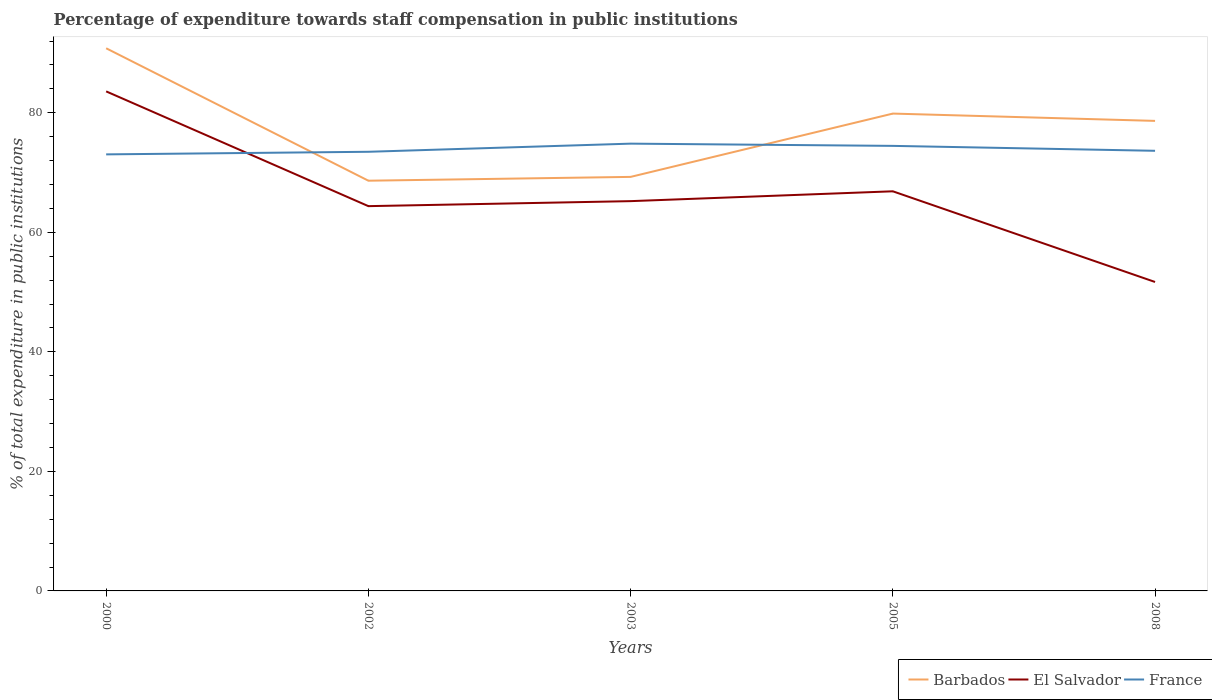Across all years, what is the maximum percentage of expenditure towards staff compensation in El Salvador?
Offer a very short reply. 51.69. What is the total percentage of expenditure towards staff compensation in France in the graph?
Give a very brief answer. -1.42. What is the difference between the highest and the second highest percentage of expenditure towards staff compensation in Barbados?
Offer a terse response. 22.16. How many lines are there?
Provide a succinct answer. 3. Does the graph contain grids?
Offer a very short reply. No. Where does the legend appear in the graph?
Your response must be concise. Bottom right. What is the title of the graph?
Ensure brevity in your answer.  Percentage of expenditure towards staff compensation in public institutions. What is the label or title of the X-axis?
Provide a short and direct response. Years. What is the label or title of the Y-axis?
Offer a terse response. % of total expenditure in public institutions. What is the % of total expenditure in public institutions of Barbados in 2000?
Offer a terse response. 90.8. What is the % of total expenditure in public institutions in El Salvador in 2000?
Offer a terse response. 83.58. What is the % of total expenditure in public institutions of France in 2000?
Make the answer very short. 73.04. What is the % of total expenditure in public institutions in Barbados in 2002?
Make the answer very short. 68.64. What is the % of total expenditure in public institutions of El Salvador in 2002?
Ensure brevity in your answer.  64.38. What is the % of total expenditure in public institutions of France in 2002?
Make the answer very short. 73.48. What is the % of total expenditure in public institutions in Barbados in 2003?
Offer a terse response. 69.28. What is the % of total expenditure in public institutions of El Salvador in 2003?
Provide a succinct answer. 65.22. What is the % of total expenditure in public institutions in France in 2003?
Provide a succinct answer. 74.84. What is the % of total expenditure in public institutions in Barbados in 2005?
Make the answer very short. 79.87. What is the % of total expenditure in public institutions in El Salvador in 2005?
Your answer should be very brief. 66.86. What is the % of total expenditure in public institutions in France in 2005?
Provide a short and direct response. 74.47. What is the % of total expenditure in public institutions in Barbados in 2008?
Your answer should be very brief. 78.65. What is the % of total expenditure in public institutions in El Salvador in 2008?
Your response must be concise. 51.69. What is the % of total expenditure in public institutions in France in 2008?
Your response must be concise. 73.64. Across all years, what is the maximum % of total expenditure in public institutions of Barbados?
Offer a very short reply. 90.8. Across all years, what is the maximum % of total expenditure in public institutions in El Salvador?
Keep it short and to the point. 83.58. Across all years, what is the maximum % of total expenditure in public institutions of France?
Your answer should be compact. 74.84. Across all years, what is the minimum % of total expenditure in public institutions of Barbados?
Your answer should be very brief. 68.64. Across all years, what is the minimum % of total expenditure in public institutions of El Salvador?
Your answer should be compact. 51.69. Across all years, what is the minimum % of total expenditure in public institutions of France?
Ensure brevity in your answer.  73.04. What is the total % of total expenditure in public institutions of Barbados in the graph?
Offer a very short reply. 387.23. What is the total % of total expenditure in public institutions in El Salvador in the graph?
Your answer should be compact. 331.74. What is the total % of total expenditure in public institutions of France in the graph?
Provide a succinct answer. 369.46. What is the difference between the % of total expenditure in public institutions of Barbados in 2000 and that in 2002?
Provide a short and direct response. 22.16. What is the difference between the % of total expenditure in public institutions of El Salvador in 2000 and that in 2002?
Offer a very short reply. 19.2. What is the difference between the % of total expenditure in public institutions of France in 2000 and that in 2002?
Keep it short and to the point. -0.43. What is the difference between the % of total expenditure in public institutions of Barbados in 2000 and that in 2003?
Provide a succinct answer. 21.52. What is the difference between the % of total expenditure in public institutions of El Salvador in 2000 and that in 2003?
Provide a short and direct response. 18.36. What is the difference between the % of total expenditure in public institutions in France in 2000 and that in 2003?
Offer a terse response. -1.8. What is the difference between the % of total expenditure in public institutions of Barbados in 2000 and that in 2005?
Ensure brevity in your answer.  10.93. What is the difference between the % of total expenditure in public institutions in El Salvador in 2000 and that in 2005?
Offer a very short reply. 16.72. What is the difference between the % of total expenditure in public institutions of France in 2000 and that in 2005?
Your response must be concise. -1.42. What is the difference between the % of total expenditure in public institutions in Barbados in 2000 and that in 2008?
Offer a very short reply. 12.15. What is the difference between the % of total expenditure in public institutions in El Salvador in 2000 and that in 2008?
Provide a short and direct response. 31.89. What is the difference between the % of total expenditure in public institutions of France in 2000 and that in 2008?
Your response must be concise. -0.6. What is the difference between the % of total expenditure in public institutions of Barbados in 2002 and that in 2003?
Ensure brevity in your answer.  -0.64. What is the difference between the % of total expenditure in public institutions in El Salvador in 2002 and that in 2003?
Make the answer very short. -0.84. What is the difference between the % of total expenditure in public institutions in France in 2002 and that in 2003?
Your answer should be compact. -1.36. What is the difference between the % of total expenditure in public institutions in Barbados in 2002 and that in 2005?
Ensure brevity in your answer.  -11.23. What is the difference between the % of total expenditure in public institutions of El Salvador in 2002 and that in 2005?
Your response must be concise. -2.48. What is the difference between the % of total expenditure in public institutions in France in 2002 and that in 2005?
Ensure brevity in your answer.  -0.99. What is the difference between the % of total expenditure in public institutions of Barbados in 2002 and that in 2008?
Provide a succinct answer. -10.01. What is the difference between the % of total expenditure in public institutions of El Salvador in 2002 and that in 2008?
Your answer should be very brief. 12.69. What is the difference between the % of total expenditure in public institutions of France in 2002 and that in 2008?
Offer a terse response. -0.17. What is the difference between the % of total expenditure in public institutions in Barbados in 2003 and that in 2005?
Give a very brief answer. -10.59. What is the difference between the % of total expenditure in public institutions in El Salvador in 2003 and that in 2005?
Ensure brevity in your answer.  -1.65. What is the difference between the % of total expenditure in public institutions of France in 2003 and that in 2005?
Offer a terse response. 0.37. What is the difference between the % of total expenditure in public institutions in Barbados in 2003 and that in 2008?
Make the answer very short. -9.37. What is the difference between the % of total expenditure in public institutions of El Salvador in 2003 and that in 2008?
Provide a short and direct response. 13.53. What is the difference between the % of total expenditure in public institutions of France in 2003 and that in 2008?
Your response must be concise. 1.2. What is the difference between the % of total expenditure in public institutions of Barbados in 2005 and that in 2008?
Your response must be concise. 1.22. What is the difference between the % of total expenditure in public institutions in El Salvador in 2005 and that in 2008?
Keep it short and to the point. 15.17. What is the difference between the % of total expenditure in public institutions in France in 2005 and that in 2008?
Make the answer very short. 0.82. What is the difference between the % of total expenditure in public institutions in Barbados in 2000 and the % of total expenditure in public institutions in El Salvador in 2002?
Give a very brief answer. 26.42. What is the difference between the % of total expenditure in public institutions in Barbados in 2000 and the % of total expenditure in public institutions in France in 2002?
Give a very brief answer. 17.32. What is the difference between the % of total expenditure in public institutions of El Salvador in 2000 and the % of total expenditure in public institutions of France in 2002?
Give a very brief answer. 10.11. What is the difference between the % of total expenditure in public institutions in Barbados in 2000 and the % of total expenditure in public institutions in El Salvador in 2003?
Give a very brief answer. 25.58. What is the difference between the % of total expenditure in public institutions of Barbados in 2000 and the % of total expenditure in public institutions of France in 2003?
Ensure brevity in your answer.  15.96. What is the difference between the % of total expenditure in public institutions in El Salvador in 2000 and the % of total expenditure in public institutions in France in 2003?
Your answer should be compact. 8.74. What is the difference between the % of total expenditure in public institutions in Barbados in 2000 and the % of total expenditure in public institutions in El Salvador in 2005?
Provide a succinct answer. 23.93. What is the difference between the % of total expenditure in public institutions of Barbados in 2000 and the % of total expenditure in public institutions of France in 2005?
Keep it short and to the point. 16.33. What is the difference between the % of total expenditure in public institutions in El Salvador in 2000 and the % of total expenditure in public institutions in France in 2005?
Offer a terse response. 9.12. What is the difference between the % of total expenditure in public institutions in Barbados in 2000 and the % of total expenditure in public institutions in El Salvador in 2008?
Provide a short and direct response. 39.11. What is the difference between the % of total expenditure in public institutions in Barbados in 2000 and the % of total expenditure in public institutions in France in 2008?
Your answer should be very brief. 17.16. What is the difference between the % of total expenditure in public institutions in El Salvador in 2000 and the % of total expenditure in public institutions in France in 2008?
Ensure brevity in your answer.  9.94. What is the difference between the % of total expenditure in public institutions in Barbados in 2002 and the % of total expenditure in public institutions in El Salvador in 2003?
Give a very brief answer. 3.42. What is the difference between the % of total expenditure in public institutions in Barbados in 2002 and the % of total expenditure in public institutions in France in 2003?
Make the answer very short. -6.2. What is the difference between the % of total expenditure in public institutions of El Salvador in 2002 and the % of total expenditure in public institutions of France in 2003?
Offer a terse response. -10.46. What is the difference between the % of total expenditure in public institutions in Barbados in 2002 and the % of total expenditure in public institutions in El Salvador in 2005?
Your answer should be compact. 1.77. What is the difference between the % of total expenditure in public institutions in Barbados in 2002 and the % of total expenditure in public institutions in France in 2005?
Provide a short and direct response. -5.83. What is the difference between the % of total expenditure in public institutions in El Salvador in 2002 and the % of total expenditure in public institutions in France in 2005?
Your answer should be compact. -10.08. What is the difference between the % of total expenditure in public institutions in Barbados in 2002 and the % of total expenditure in public institutions in El Salvador in 2008?
Offer a very short reply. 16.95. What is the difference between the % of total expenditure in public institutions in Barbados in 2002 and the % of total expenditure in public institutions in France in 2008?
Offer a very short reply. -5. What is the difference between the % of total expenditure in public institutions of El Salvador in 2002 and the % of total expenditure in public institutions of France in 2008?
Give a very brief answer. -9.26. What is the difference between the % of total expenditure in public institutions in Barbados in 2003 and the % of total expenditure in public institutions in El Salvador in 2005?
Offer a very short reply. 2.41. What is the difference between the % of total expenditure in public institutions in Barbados in 2003 and the % of total expenditure in public institutions in France in 2005?
Make the answer very short. -5.19. What is the difference between the % of total expenditure in public institutions in El Salvador in 2003 and the % of total expenditure in public institutions in France in 2005?
Offer a terse response. -9.25. What is the difference between the % of total expenditure in public institutions in Barbados in 2003 and the % of total expenditure in public institutions in El Salvador in 2008?
Offer a very short reply. 17.58. What is the difference between the % of total expenditure in public institutions in Barbados in 2003 and the % of total expenditure in public institutions in France in 2008?
Your response must be concise. -4.37. What is the difference between the % of total expenditure in public institutions in El Salvador in 2003 and the % of total expenditure in public institutions in France in 2008?
Offer a terse response. -8.42. What is the difference between the % of total expenditure in public institutions in Barbados in 2005 and the % of total expenditure in public institutions in El Salvador in 2008?
Offer a terse response. 28.18. What is the difference between the % of total expenditure in public institutions of Barbados in 2005 and the % of total expenditure in public institutions of France in 2008?
Offer a terse response. 6.23. What is the difference between the % of total expenditure in public institutions of El Salvador in 2005 and the % of total expenditure in public institutions of France in 2008?
Ensure brevity in your answer.  -6.78. What is the average % of total expenditure in public institutions in Barbados per year?
Offer a terse response. 77.44. What is the average % of total expenditure in public institutions of El Salvador per year?
Provide a short and direct response. 66.35. What is the average % of total expenditure in public institutions of France per year?
Provide a succinct answer. 73.89. In the year 2000, what is the difference between the % of total expenditure in public institutions of Barbados and % of total expenditure in public institutions of El Salvador?
Your response must be concise. 7.21. In the year 2000, what is the difference between the % of total expenditure in public institutions in Barbados and % of total expenditure in public institutions in France?
Your answer should be compact. 17.76. In the year 2000, what is the difference between the % of total expenditure in public institutions in El Salvador and % of total expenditure in public institutions in France?
Offer a very short reply. 10.54. In the year 2002, what is the difference between the % of total expenditure in public institutions in Barbados and % of total expenditure in public institutions in El Salvador?
Your answer should be compact. 4.26. In the year 2002, what is the difference between the % of total expenditure in public institutions of Barbados and % of total expenditure in public institutions of France?
Your answer should be very brief. -4.84. In the year 2002, what is the difference between the % of total expenditure in public institutions of El Salvador and % of total expenditure in public institutions of France?
Give a very brief answer. -9.09. In the year 2003, what is the difference between the % of total expenditure in public institutions in Barbados and % of total expenditure in public institutions in El Salvador?
Ensure brevity in your answer.  4.06. In the year 2003, what is the difference between the % of total expenditure in public institutions in Barbados and % of total expenditure in public institutions in France?
Your response must be concise. -5.56. In the year 2003, what is the difference between the % of total expenditure in public institutions in El Salvador and % of total expenditure in public institutions in France?
Your answer should be compact. -9.62. In the year 2005, what is the difference between the % of total expenditure in public institutions in Barbados and % of total expenditure in public institutions in El Salvador?
Provide a succinct answer. 13. In the year 2005, what is the difference between the % of total expenditure in public institutions of Barbados and % of total expenditure in public institutions of France?
Your response must be concise. 5.4. In the year 2005, what is the difference between the % of total expenditure in public institutions in El Salvador and % of total expenditure in public institutions in France?
Your response must be concise. -7.6. In the year 2008, what is the difference between the % of total expenditure in public institutions in Barbados and % of total expenditure in public institutions in El Salvador?
Provide a short and direct response. 26.95. In the year 2008, what is the difference between the % of total expenditure in public institutions in Barbados and % of total expenditure in public institutions in France?
Provide a short and direct response. 5. In the year 2008, what is the difference between the % of total expenditure in public institutions in El Salvador and % of total expenditure in public institutions in France?
Provide a short and direct response. -21.95. What is the ratio of the % of total expenditure in public institutions of Barbados in 2000 to that in 2002?
Your answer should be compact. 1.32. What is the ratio of the % of total expenditure in public institutions in El Salvador in 2000 to that in 2002?
Your response must be concise. 1.3. What is the ratio of the % of total expenditure in public institutions of Barbados in 2000 to that in 2003?
Offer a very short reply. 1.31. What is the ratio of the % of total expenditure in public institutions in El Salvador in 2000 to that in 2003?
Make the answer very short. 1.28. What is the ratio of the % of total expenditure in public institutions in Barbados in 2000 to that in 2005?
Keep it short and to the point. 1.14. What is the ratio of the % of total expenditure in public institutions of El Salvador in 2000 to that in 2005?
Offer a terse response. 1.25. What is the ratio of the % of total expenditure in public institutions of France in 2000 to that in 2005?
Your answer should be very brief. 0.98. What is the ratio of the % of total expenditure in public institutions in Barbados in 2000 to that in 2008?
Your answer should be compact. 1.15. What is the ratio of the % of total expenditure in public institutions of El Salvador in 2000 to that in 2008?
Provide a short and direct response. 1.62. What is the ratio of the % of total expenditure in public institutions in France in 2000 to that in 2008?
Give a very brief answer. 0.99. What is the ratio of the % of total expenditure in public institutions of El Salvador in 2002 to that in 2003?
Give a very brief answer. 0.99. What is the ratio of the % of total expenditure in public institutions in France in 2002 to that in 2003?
Provide a succinct answer. 0.98. What is the ratio of the % of total expenditure in public institutions in Barbados in 2002 to that in 2005?
Provide a short and direct response. 0.86. What is the ratio of the % of total expenditure in public institutions in El Salvador in 2002 to that in 2005?
Make the answer very short. 0.96. What is the ratio of the % of total expenditure in public institutions of France in 2002 to that in 2005?
Your answer should be very brief. 0.99. What is the ratio of the % of total expenditure in public institutions in Barbados in 2002 to that in 2008?
Provide a short and direct response. 0.87. What is the ratio of the % of total expenditure in public institutions of El Salvador in 2002 to that in 2008?
Offer a terse response. 1.25. What is the ratio of the % of total expenditure in public institutions of Barbados in 2003 to that in 2005?
Make the answer very short. 0.87. What is the ratio of the % of total expenditure in public institutions in El Salvador in 2003 to that in 2005?
Offer a very short reply. 0.98. What is the ratio of the % of total expenditure in public institutions of Barbados in 2003 to that in 2008?
Ensure brevity in your answer.  0.88. What is the ratio of the % of total expenditure in public institutions in El Salvador in 2003 to that in 2008?
Provide a short and direct response. 1.26. What is the ratio of the % of total expenditure in public institutions in France in 2003 to that in 2008?
Keep it short and to the point. 1.02. What is the ratio of the % of total expenditure in public institutions of Barbados in 2005 to that in 2008?
Your response must be concise. 1.02. What is the ratio of the % of total expenditure in public institutions of El Salvador in 2005 to that in 2008?
Provide a short and direct response. 1.29. What is the ratio of the % of total expenditure in public institutions of France in 2005 to that in 2008?
Offer a terse response. 1.01. What is the difference between the highest and the second highest % of total expenditure in public institutions in Barbados?
Keep it short and to the point. 10.93. What is the difference between the highest and the second highest % of total expenditure in public institutions of El Salvador?
Provide a succinct answer. 16.72. What is the difference between the highest and the second highest % of total expenditure in public institutions in France?
Keep it short and to the point. 0.37. What is the difference between the highest and the lowest % of total expenditure in public institutions of Barbados?
Ensure brevity in your answer.  22.16. What is the difference between the highest and the lowest % of total expenditure in public institutions in El Salvador?
Make the answer very short. 31.89. What is the difference between the highest and the lowest % of total expenditure in public institutions in France?
Your answer should be compact. 1.8. 